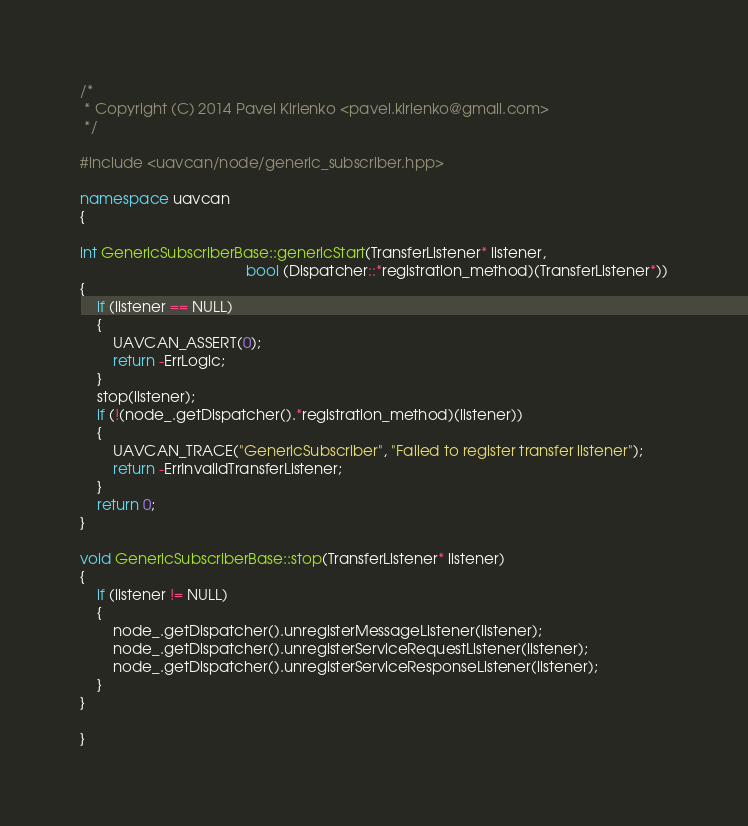Convert code to text. <code><loc_0><loc_0><loc_500><loc_500><_C++_>/*
 * Copyright (C) 2014 Pavel Kirienko <pavel.kirienko@gmail.com>
 */

#include <uavcan/node/generic_subscriber.hpp>

namespace uavcan
{

int GenericSubscriberBase::genericStart(TransferListener* listener,
                                        bool (Dispatcher::*registration_method)(TransferListener*))
{
    if (listener == NULL)
    {
        UAVCAN_ASSERT(0);
        return -ErrLogic;
    }
    stop(listener);
    if (!(node_.getDispatcher().*registration_method)(listener))
    {
        UAVCAN_TRACE("GenericSubscriber", "Failed to register transfer listener");
        return -ErrInvalidTransferListener;
    }
    return 0;
}

void GenericSubscriberBase::stop(TransferListener* listener)
{
    if (listener != NULL)
    {
        node_.getDispatcher().unregisterMessageListener(listener);
        node_.getDispatcher().unregisterServiceRequestListener(listener);
        node_.getDispatcher().unregisterServiceResponseListener(listener);
    }
}

}
</code> 